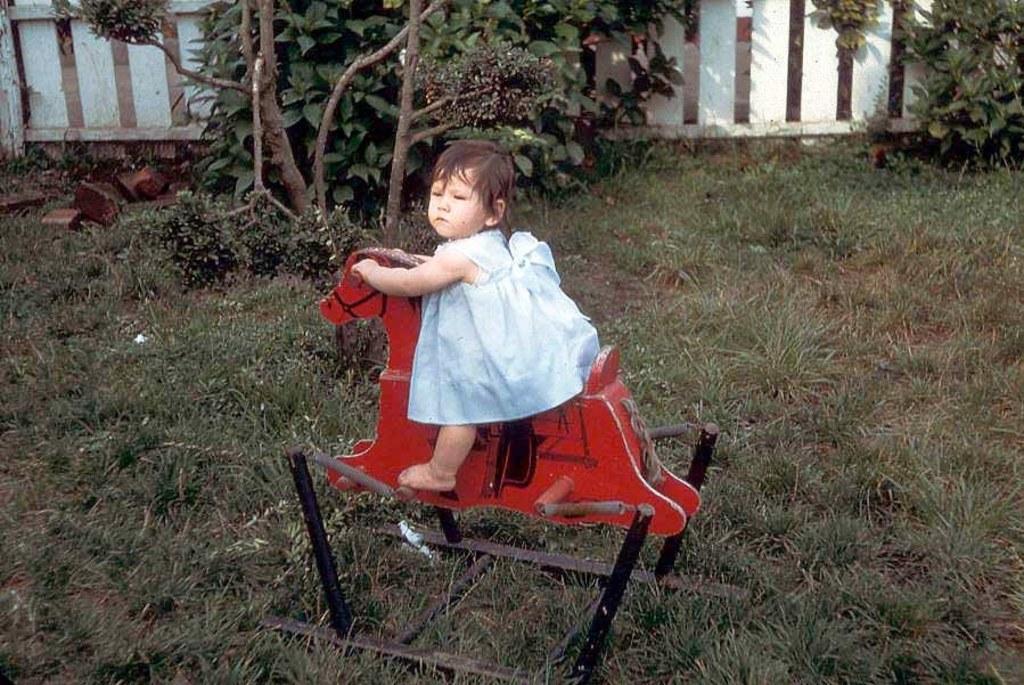Please provide a concise description of this image. In this image a baby girl is sitting on a toy horse. In the background there are trees, wooden fence. On the ground there are grasses. 